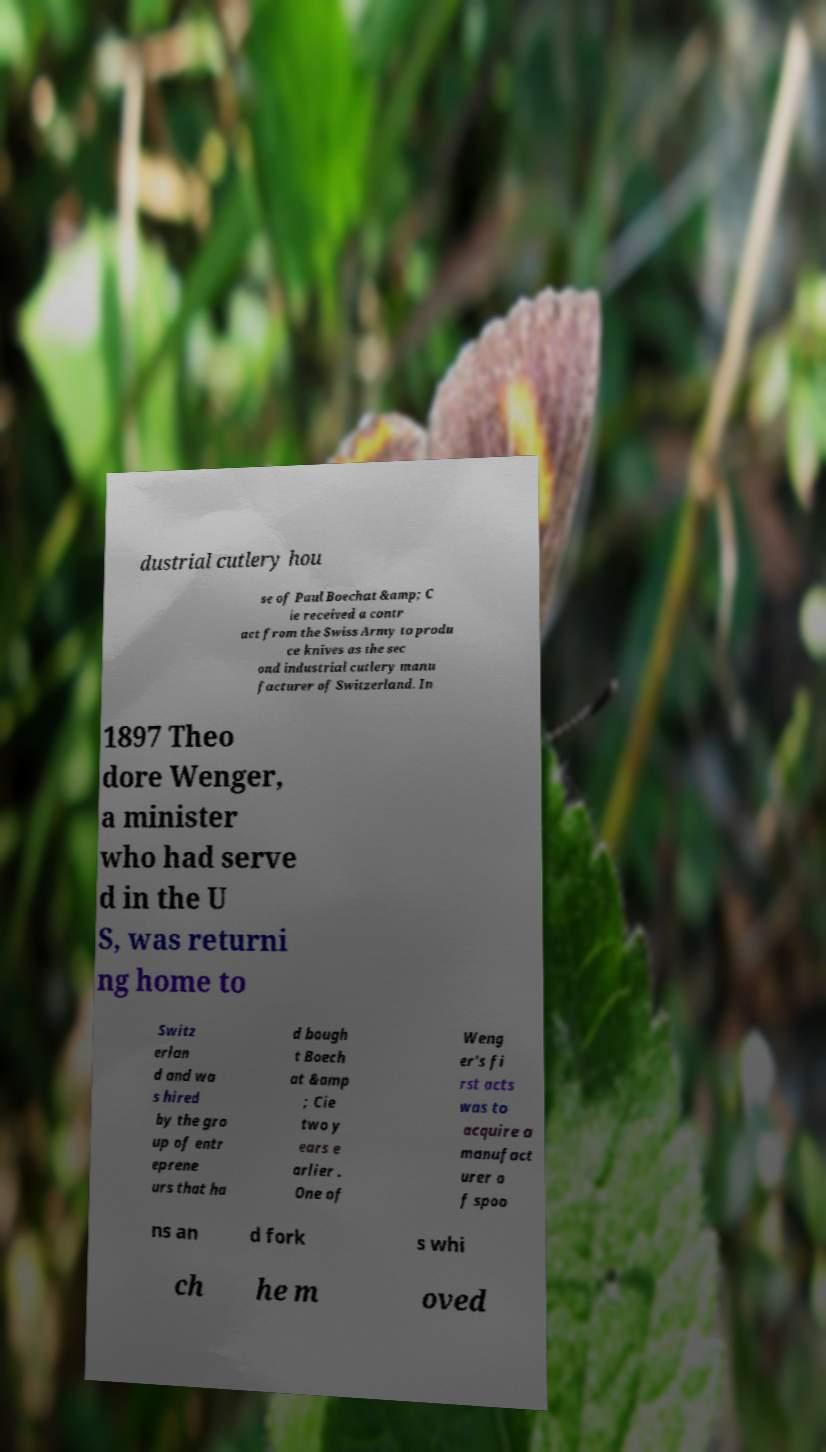Could you extract and type out the text from this image? dustrial cutlery hou se of Paul Boechat &amp; C ie received a contr act from the Swiss Army to produ ce knives as the sec ond industrial cutlery manu facturer of Switzerland. In 1897 Theo dore Wenger, a minister who had serve d in the U S, was returni ng home to Switz erlan d and wa s hired by the gro up of entr eprene urs that ha d bough t Boech at &amp ; Cie two y ears e arlier . One of Weng er's fi rst acts was to acquire a manufact urer o f spoo ns an d fork s whi ch he m oved 